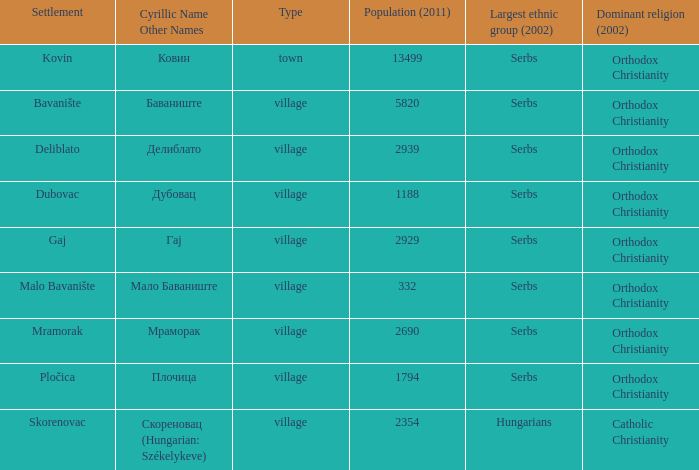What is the Deliblato village known as in Cyrillic? Делиблато. 